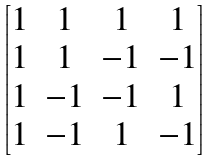Convert formula to latex. <formula><loc_0><loc_0><loc_500><loc_500>\begin{bmatrix} 1 & 1 & 1 & 1 \\ 1 & 1 & - 1 & - 1 \\ 1 & - 1 & - 1 & 1 \\ 1 & - 1 & 1 & - 1 \end{bmatrix}</formula> 